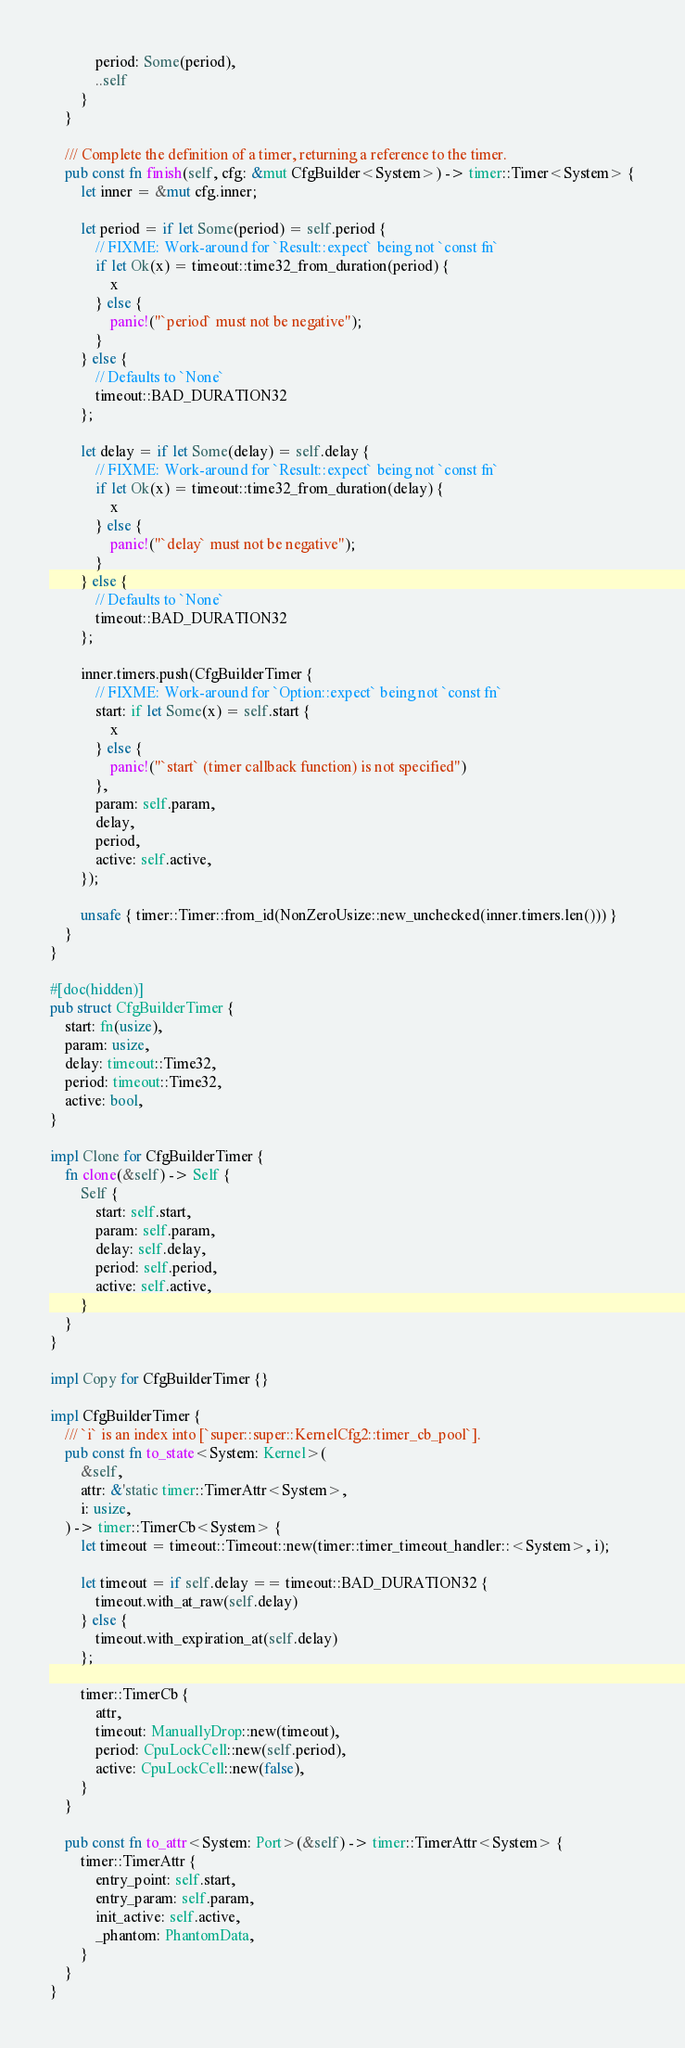Convert code to text. <code><loc_0><loc_0><loc_500><loc_500><_Rust_>            period: Some(period),
            ..self
        }
    }

    /// Complete the definition of a timer, returning a reference to the timer.
    pub const fn finish(self, cfg: &mut CfgBuilder<System>) -> timer::Timer<System> {
        let inner = &mut cfg.inner;

        let period = if let Some(period) = self.period {
            // FIXME: Work-around for `Result::expect` being not `const fn`
            if let Ok(x) = timeout::time32_from_duration(period) {
                x
            } else {
                panic!("`period` must not be negative");
            }
        } else {
            // Defaults to `None`
            timeout::BAD_DURATION32
        };

        let delay = if let Some(delay) = self.delay {
            // FIXME: Work-around for `Result::expect` being not `const fn`
            if let Ok(x) = timeout::time32_from_duration(delay) {
                x
            } else {
                panic!("`delay` must not be negative");
            }
        } else {
            // Defaults to `None`
            timeout::BAD_DURATION32
        };

        inner.timers.push(CfgBuilderTimer {
            // FIXME: Work-around for `Option::expect` being not `const fn`
            start: if let Some(x) = self.start {
                x
            } else {
                panic!("`start` (timer callback function) is not specified")
            },
            param: self.param,
            delay,
            period,
            active: self.active,
        });

        unsafe { timer::Timer::from_id(NonZeroUsize::new_unchecked(inner.timers.len())) }
    }
}

#[doc(hidden)]
pub struct CfgBuilderTimer {
    start: fn(usize),
    param: usize,
    delay: timeout::Time32,
    period: timeout::Time32,
    active: bool,
}

impl Clone for CfgBuilderTimer {
    fn clone(&self) -> Self {
        Self {
            start: self.start,
            param: self.param,
            delay: self.delay,
            period: self.period,
            active: self.active,
        }
    }
}

impl Copy for CfgBuilderTimer {}

impl CfgBuilderTimer {
    /// `i` is an index into [`super::super::KernelCfg2::timer_cb_pool`].
    pub const fn to_state<System: Kernel>(
        &self,
        attr: &'static timer::TimerAttr<System>,
        i: usize,
    ) -> timer::TimerCb<System> {
        let timeout = timeout::Timeout::new(timer::timer_timeout_handler::<System>, i);

        let timeout = if self.delay == timeout::BAD_DURATION32 {
            timeout.with_at_raw(self.delay)
        } else {
            timeout.with_expiration_at(self.delay)
        };

        timer::TimerCb {
            attr,
            timeout: ManuallyDrop::new(timeout),
            period: CpuLockCell::new(self.period),
            active: CpuLockCell::new(false),
        }
    }

    pub const fn to_attr<System: Port>(&self) -> timer::TimerAttr<System> {
        timer::TimerAttr {
            entry_point: self.start,
            entry_param: self.param,
            init_active: self.active,
            _phantom: PhantomData,
        }
    }
}
</code> 